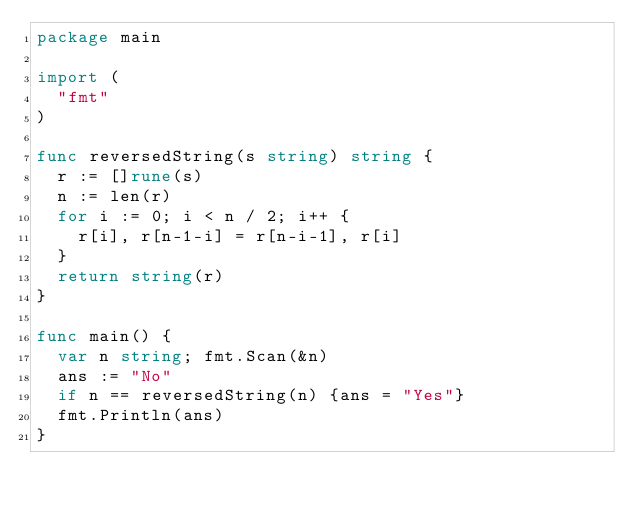<code> <loc_0><loc_0><loc_500><loc_500><_Go_>package main

import (
  "fmt"
)

func reversedString(s string) string {
  r := []rune(s)
  n := len(r)
  for i := 0; i < n / 2; i++ {
    r[i], r[n-1-i] = r[n-i-1], r[i]
  }
  return string(r)
}

func main() {
  var n string; fmt.Scan(&n)
  ans := "No"
  if n == reversedString(n) {ans = "Yes"}
  fmt.Println(ans)
}</code> 